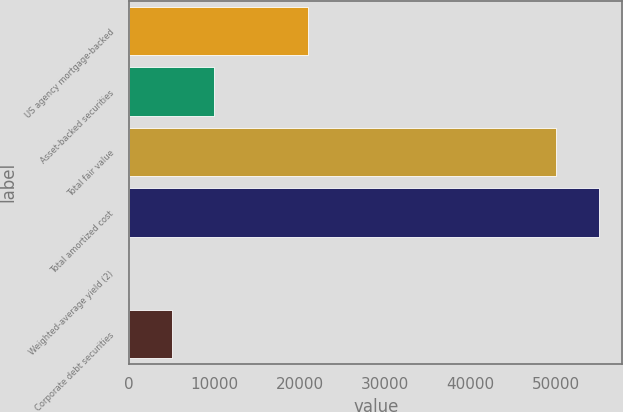Convert chart to OTSL. <chart><loc_0><loc_0><loc_500><loc_500><bar_chart><fcel>US agency mortgage-backed<fcel>Asset-backed securities<fcel>Total fair value<fcel>Total amortized cost<fcel>Weighted-average yield (2)<fcel>Corporate debt securities<nl><fcel>20929<fcel>10007.1<fcel>49995<fcel>54997.7<fcel>1.66<fcel>5004.39<nl></chart> 